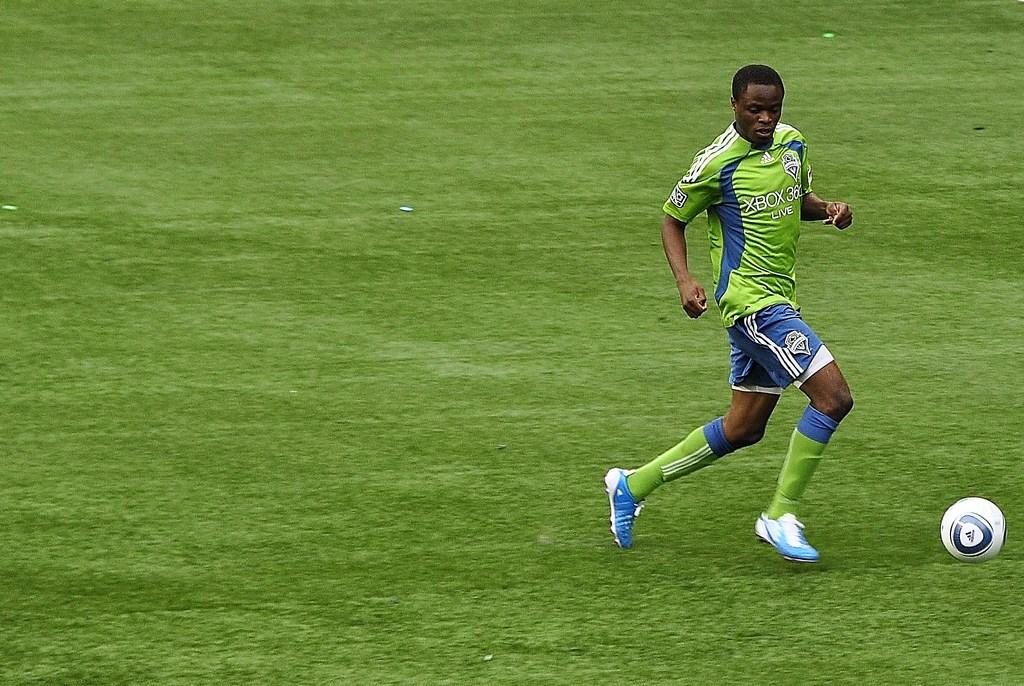<image>
Offer a succinct explanation of the picture presented. A soccer player with X Box 360 on the front of his jersey 